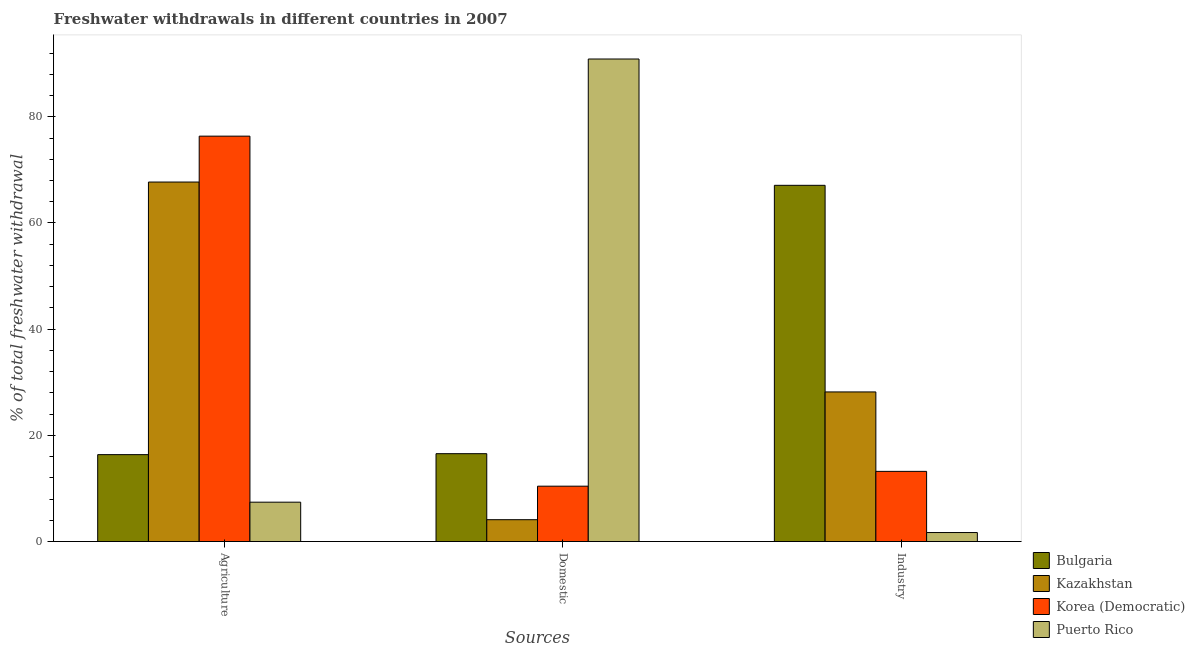How many bars are there on the 2nd tick from the right?
Offer a terse response. 4. What is the label of the 1st group of bars from the left?
Ensure brevity in your answer.  Agriculture. What is the percentage of freshwater withdrawal for industry in Puerto Rico?
Keep it short and to the point. 1.7. Across all countries, what is the maximum percentage of freshwater withdrawal for domestic purposes?
Provide a succinct answer. 90.88. Across all countries, what is the minimum percentage of freshwater withdrawal for agriculture?
Make the answer very short. 7.42. In which country was the percentage of freshwater withdrawal for domestic purposes maximum?
Give a very brief answer. Puerto Rico. In which country was the percentage of freshwater withdrawal for domestic purposes minimum?
Your response must be concise. Kazakhstan. What is the total percentage of freshwater withdrawal for industry in the graph?
Make the answer very short. 110.19. What is the difference between the percentage of freshwater withdrawal for domestic purposes in Bulgaria and that in Puerto Rico?
Provide a succinct answer. -74.33. What is the difference between the percentage of freshwater withdrawal for domestic purposes in Korea (Democratic) and the percentage of freshwater withdrawal for agriculture in Puerto Rico?
Make the answer very short. 3.01. What is the average percentage of freshwater withdrawal for domestic purposes per country?
Ensure brevity in your answer.  30.49. What is the difference between the percentage of freshwater withdrawal for domestic purposes and percentage of freshwater withdrawal for agriculture in Kazakhstan?
Offer a very short reply. -63.59. In how many countries, is the percentage of freshwater withdrawal for industry greater than 8 %?
Your answer should be compact. 3. What is the ratio of the percentage of freshwater withdrawal for industry in Puerto Rico to that in Kazakhstan?
Provide a short and direct response. 0.06. Is the percentage of freshwater withdrawal for industry in Puerto Rico less than that in Kazakhstan?
Make the answer very short. Yes. What is the difference between the highest and the second highest percentage of freshwater withdrawal for industry?
Your answer should be very brief. 38.91. What is the difference between the highest and the lowest percentage of freshwater withdrawal for industry?
Your answer should be compact. 65.39. Is the sum of the percentage of freshwater withdrawal for industry in Korea (Democratic) and Kazakhstan greater than the maximum percentage of freshwater withdrawal for agriculture across all countries?
Give a very brief answer. No. What does the 2nd bar from the left in Domestic represents?
Your response must be concise. Kazakhstan. What does the 3rd bar from the right in Agriculture represents?
Offer a terse response. Kazakhstan. Are all the bars in the graph horizontal?
Give a very brief answer. No. How many legend labels are there?
Give a very brief answer. 4. What is the title of the graph?
Offer a terse response. Freshwater withdrawals in different countries in 2007. What is the label or title of the X-axis?
Make the answer very short. Sources. What is the label or title of the Y-axis?
Provide a short and direct response. % of total freshwater withdrawal. What is the % of total freshwater withdrawal of Bulgaria in Agriculture?
Your answer should be compact. 16.37. What is the % of total freshwater withdrawal of Kazakhstan in Agriculture?
Offer a very short reply. 67.71. What is the % of total freshwater withdrawal in Korea (Democratic) in Agriculture?
Provide a short and direct response. 76.35. What is the % of total freshwater withdrawal in Puerto Rico in Agriculture?
Give a very brief answer. 7.42. What is the % of total freshwater withdrawal in Bulgaria in Domestic?
Ensure brevity in your answer.  16.55. What is the % of total freshwater withdrawal of Kazakhstan in Domestic?
Provide a succinct answer. 4.12. What is the % of total freshwater withdrawal of Korea (Democratic) in Domestic?
Provide a succinct answer. 10.43. What is the % of total freshwater withdrawal of Puerto Rico in Domestic?
Your answer should be compact. 90.88. What is the % of total freshwater withdrawal in Bulgaria in Industry?
Your response must be concise. 67.09. What is the % of total freshwater withdrawal of Kazakhstan in Industry?
Keep it short and to the point. 28.18. What is the % of total freshwater withdrawal in Korea (Democratic) in Industry?
Ensure brevity in your answer.  13.22. What is the % of total freshwater withdrawal of Puerto Rico in Industry?
Provide a succinct answer. 1.7. Across all Sources, what is the maximum % of total freshwater withdrawal of Bulgaria?
Keep it short and to the point. 67.09. Across all Sources, what is the maximum % of total freshwater withdrawal of Kazakhstan?
Offer a very short reply. 67.71. Across all Sources, what is the maximum % of total freshwater withdrawal of Korea (Democratic)?
Make the answer very short. 76.35. Across all Sources, what is the maximum % of total freshwater withdrawal in Puerto Rico?
Offer a very short reply. 90.88. Across all Sources, what is the minimum % of total freshwater withdrawal in Bulgaria?
Provide a short and direct response. 16.37. Across all Sources, what is the minimum % of total freshwater withdrawal of Kazakhstan?
Give a very brief answer. 4.12. Across all Sources, what is the minimum % of total freshwater withdrawal of Korea (Democratic)?
Offer a terse response. 10.43. Across all Sources, what is the minimum % of total freshwater withdrawal in Puerto Rico?
Your answer should be compact. 1.7. What is the total % of total freshwater withdrawal in Bulgaria in the graph?
Your answer should be compact. 100.01. What is the total % of total freshwater withdrawal in Kazakhstan in the graph?
Offer a terse response. 100.01. What is the total % of total freshwater withdrawal of Korea (Democratic) in the graph?
Provide a succinct answer. 100. What is the total % of total freshwater withdrawal of Puerto Rico in the graph?
Provide a succinct answer. 100. What is the difference between the % of total freshwater withdrawal in Bulgaria in Agriculture and that in Domestic?
Keep it short and to the point. -0.18. What is the difference between the % of total freshwater withdrawal in Kazakhstan in Agriculture and that in Domestic?
Give a very brief answer. 63.59. What is the difference between the % of total freshwater withdrawal of Korea (Democratic) in Agriculture and that in Domestic?
Make the answer very short. 65.92. What is the difference between the % of total freshwater withdrawal of Puerto Rico in Agriculture and that in Domestic?
Give a very brief answer. -83.46. What is the difference between the % of total freshwater withdrawal in Bulgaria in Agriculture and that in Industry?
Your answer should be compact. -50.72. What is the difference between the % of total freshwater withdrawal in Kazakhstan in Agriculture and that in Industry?
Your answer should be compact. 39.53. What is the difference between the % of total freshwater withdrawal of Korea (Democratic) in Agriculture and that in Industry?
Provide a short and direct response. 63.13. What is the difference between the % of total freshwater withdrawal in Puerto Rico in Agriculture and that in Industry?
Your response must be concise. 5.72. What is the difference between the % of total freshwater withdrawal of Bulgaria in Domestic and that in Industry?
Provide a short and direct response. -50.54. What is the difference between the % of total freshwater withdrawal in Kazakhstan in Domestic and that in Industry?
Ensure brevity in your answer.  -24.06. What is the difference between the % of total freshwater withdrawal of Korea (Democratic) in Domestic and that in Industry?
Ensure brevity in your answer.  -2.79. What is the difference between the % of total freshwater withdrawal of Puerto Rico in Domestic and that in Industry?
Your answer should be very brief. 89.18. What is the difference between the % of total freshwater withdrawal of Bulgaria in Agriculture and the % of total freshwater withdrawal of Kazakhstan in Domestic?
Make the answer very short. 12.25. What is the difference between the % of total freshwater withdrawal in Bulgaria in Agriculture and the % of total freshwater withdrawal in Korea (Democratic) in Domestic?
Make the answer very short. 5.94. What is the difference between the % of total freshwater withdrawal of Bulgaria in Agriculture and the % of total freshwater withdrawal of Puerto Rico in Domestic?
Make the answer very short. -74.51. What is the difference between the % of total freshwater withdrawal in Kazakhstan in Agriculture and the % of total freshwater withdrawal in Korea (Democratic) in Domestic?
Give a very brief answer. 57.28. What is the difference between the % of total freshwater withdrawal of Kazakhstan in Agriculture and the % of total freshwater withdrawal of Puerto Rico in Domestic?
Your answer should be very brief. -23.17. What is the difference between the % of total freshwater withdrawal of Korea (Democratic) in Agriculture and the % of total freshwater withdrawal of Puerto Rico in Domestic?
Your answer should be compact. -14.53. What is the difference between the % of total freshwater withdrawal of Bulgaria in Agriculture and the % of total freshwater withdrawal of Kazakhstan in Industry?
Provide a short and direct response. -11.81. What is the difference between the % of total freshwater withdrawal in Bulgaria in Agriculture and the % of total freshwater withdrawal in Korea (Democratic) in Industry?
Your response must be concise. 3.15. What is the difference between the % of total freshwater withdrawal of Bulgaria in Agriculture and the % of total freshwater withdrawal of Puerto Rico in Industry?
Your answer should be compact. 14.67. What is the difference between the % of total freshwater withdrawal of Kazakhstan in Agriculture and the % of total freshwater withdrawal of Korea (Democratic) in Industry?
Keep it short and to the point. 54.49. What is the difference between the % of total freshwater withdrawal in Kazakhstan in Agriculture and the % of total freshwater withdrawal in Puerto Rico in Industry?
Your answer should be compact. 66.01. What is the difference between the % of total freshwater withdrawal of Korea (Democratic) in Agriculture and the % of total freshwater withdrawal of Puerto Rico in Industry?
Make the answer very short. 74.65. What is the difference between the % of total freshwater withdrawal of Bulgaria in Domestic and the % of total freshwater withdrawal of Kazakhstan in Industry?
Ensure brevity in your answer.  -11.63. What is the difference between the % of total freshwater withdrawal in Bulgaria in Domestic and the % of total freshwater withdrawal in Korea (Democratic) in Industry?
Offer a terse response. 3.33. What is the difference between the % of total freshwater withdrawal of Bulgaria in Domestic and the % of total freshwater withdrawal of Puerto Rico in Industry?
Make the answer very short. 14.85. What is the difference between the % of total freshwater withdrawal in Kazakhstan in Domestic and the % of total freshwater withdrawal in Korea (Democratic) in Industry?
Your answer should be very brief. -9.1. What is the difference between the % of total freshwater withdrawal of Kazakhstan in Domestic and the % of total freshwater withdrawal of Puerto Rico in Industry?
Make the answer very short. 2.42. What is the difference between the % of total freshwater withdrawal in Korea (Democratic) in Domestic and the % of total freshwater withdrawal in Puerto Rico in Industry?
Keep it short and to the point. 8.73. What is the average % of total freshwater withdrawal of Bulgaria per Sources?
Your answer should be very brief. 33.34. What is the average % of total freshwater withdrawal in Kazakhstan per Sources?
Offer a very short reply. 33.34. What is the average % of total freshwater withdrawal in Korea (Democratic) per Sources?
Offer a very short reply. 33.33. What is the average % of total freshwater withdrawal of Puerto Rico per Sources?
Make the answer very short. 33.33. What is the difference between the % of total freshwater withdrawal of Bulgaria and % of total freshwater withdrawal of Kazakhstan in Agriculture?
Ensure brevity in your answer.  -51.34. What is the difference between the % of total freshwater withdrawal in Bulgaria and % of total freshwater withdrawal in Korea (Democratic) in Agriculture?
Make the answer very short. -59.98. What is the difference between the % of total freshwater withdrawal of Bulgaria and % of total freshwater withdrawal of Puerto Rico in Agriculture?
Give a very brief answer. 8.95. What is the difference between the % of total freshwater withdrawal in Kazakhstan and % of total freshwater withdrawal in Korea (Democratic) in Agriculture?
Ensure brevity in your answer.  -8.64. What is the difference between the % of total freshwater withdrawal of Kazakhstan and % of total freshwater withdrawal of Puerto Rico in Agriculture?
Offer a terse response. 60.29. What is the difference between the % of total freshwater withdrawal in Korea (Democratic) and % of total freshwater withdrawal in Puerto Rico in Agriculture?
Ensure brevity in your answer.  68.93. What is the difference between the % of total freshwater withdrawal of Bulgaria and % of total freshwater withdrawal of Kazakhstan in Domestic?
Provide a succinct answer. 12.43. What is the difference between the % of total freshwater withdrawal of Bulgaria and % of total freshwater withdrawal of Korea (Democratic) in Domestic?
Your answer should be very brief. 6.12. What is the difference between the % of total freshwater withdrawal in Bulgaria and % of total freshwater withdrawal in Puerto Rico in Domestic?
Make the answer very short. -74.33. What is the difference between the % of total freshwater withdrawal in Kazakhstan and % of total freshwater withdrawal in Korea (Democratic) in Domestic?
Keep it short and to the point. -6.31. What is the difference between the % of total freshwater withdrawal in Kazakhstan and % of total freshwater withdrawal in Puerto Rico in Domestic?
Provide a succinct answer. -86.76. What is the difference between the % of total freshwater withdrawal in Korea (Democratic) and % of total freshwater withdrawal in Puerto Rico in Domestic?
Give a very brief answer. -80.45. What is the difference between the % of total freshwater withdrawal of Bulgaria and % of total freshwater withdrawal of Kazakhstan in Industry?
Offer a very short reply. 38.91. What is the difference between the % of total freshwater withdrawal in Bulgaria and % of total freshwater withdrawal in Korea (Democratic) in Industry?
Your response must be concise. 53.87. What is the difference between the % of total freshwater withdrawal of Bulgaria and % of total freshwater withdrawal of Puerto Rico in Industry?
Ensure brevity in your answer.  65.39. What is the difference between the % of total freshwater withdrawal of Kazakhstan and % of total freshwater withdrawal of Korea (Democratic) in Industry?
Provide a short and direct response. 14.96. What is the difference between the % of total freshwater withdrawal of Kazakhstan and % of total freshwater withdrawal of Puerto Rico in Industry?
Provide a short and direct response. 26.48. What is the difference between the % of total freshwater withdrawal in Korea (Democratic) and % of total freshwater withdrawal in Puerto Rico in Industry?
Your response must be concise. 11.52. What is the ratio of the % of total freshwater withdrawal of Bulgaria in Agriculture to that in Domestic?
Keep it short and to the point. 0.99. What is the ratio of the % of total freshwater withdrawal of Kazakhstan in Agriculture to that in Domestic?
Ensure brevity in your answer.  16.45. What is the ratio of the % of total freshwater withdrawal in Korea (Democratic) in Agriculture to that in Domestic?
Offer a very short reply. 7.32. What is the ratio of the % of total freshwater withdrawal in Puerto Rico in Agriculture to that in Domestic?
Your answer should be very brief. 0.08. What is the ratio of the % of total freshwater withdrawal of Bulgaria in Agriculture to that in Industry?
Your answer should be compact. 0.24. What is the ratio of the % of total freshwater withdrawal in Kazakhstan in Agriculture to that in Industry?
Offer a very short reply. 2.4. What is the ratio of the % of total freshwater withdrawal in Korea (Democratic) in Agriculture to that in Industry?
Offer a terse response. 5.78. What is the ratio of the % of total freshwater withdrawal in Puerto Rico in Agriculture to that in Industry?
Your answer should be compact. 4.37. What is the ratio of the % of total freshwater withdrawal in Bulgaria in Domestic to that in Industry?
Give a very brief answer. 0.25. What is the ratio of the % of total freshwater withdrawal in Kazakhstan in Domestic to that in Industry?
Provide a succinct answer. 0.15. What is the ratio of the % of total freshwater withdrawal of Korea (Democratic) in Domestic to that in Industry?
Make the answer very short. 0.79. What is the ratio of the % of total freshwater withdrawal of Puerto Rico in Domestic to that in Industry?
Keep it short and to the point. 53.52. What is the difference between the highest and the second highest % of total freshwater withdrawal in Bulgaria?
Offer a very short reply. 50.54. What is the difference between the highest and the second highest % of total freshwater withdrawal of Kazakhstan?
Ensure brevity in your answer.  39.53. What is the difference between the highest and the second highest % of total freshwater withdrawal of Korea (Democratic)?
Make the answer very short. 63.13. What is the difference between the highest and the second highest % of total freshwater withdrawal in Puerto Rico?
Your answer should be compact. 83.46. What is the difference between the highest and the lowest % of total freshwater withdrawal in Bulgaria?
Keep it short and to the point. 50.72. What is the difference between the highest and the lowest % of total freshwater withdrawal in Kazakhstan?
Ensure brevity in your answer.  63.59. What is the difference between the highest and the lowest % of total freshwater withdrawal in Korea (Democratic)?
Provide a short and direct response. 65.92. What is the difference between the highest and the lowest % of total freshwater withdrawal of Puerto Rico?
Your response must be concise. 89.18. 